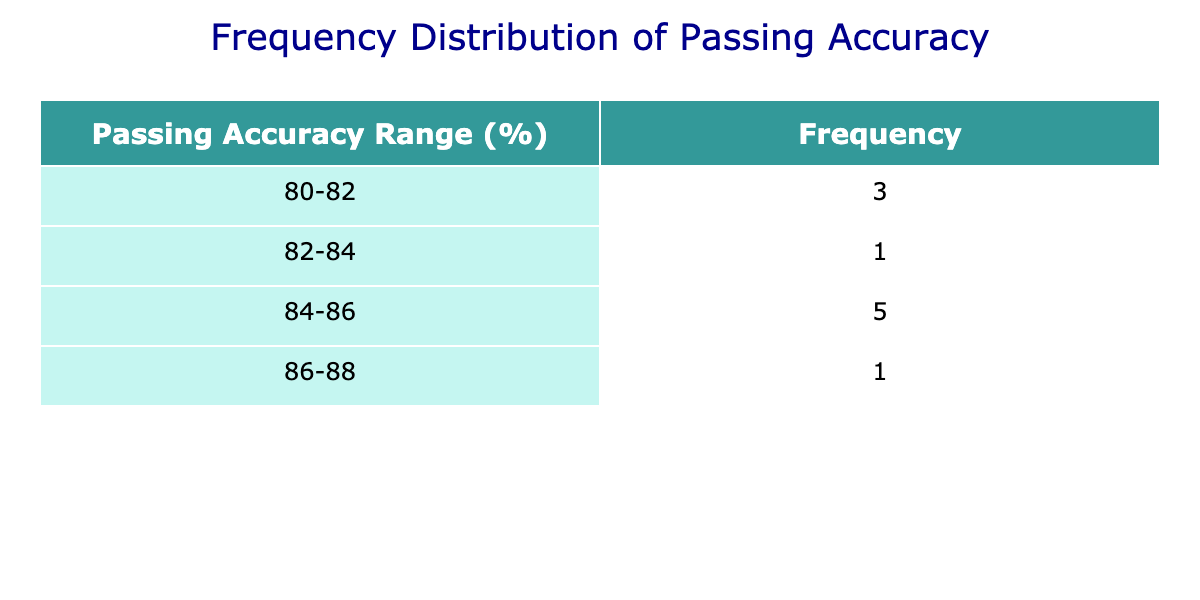What is the frequency of players with a passing accuracy between 84% and 86%? From the table, we look at the 'Accuracy Range' column and find the grouping '84-86'. The count in this category is 5 players: Kevin De Bruyne, Luka Modrić, Bruno Fernandes, Thomas Müller, and N'Golo Kanté.
Answer: 5 Which player has the highest passing accuracy? Reviewing the passing accuracy statistics, Kevin De Bruyne has the highest value of 86.7%.
Answer: Kevin De Bruyne Is there any player with a passing accuracy below 80%? By inspecting the table, the lowest recorded passing accuracy is 80%, attributed to both Jordan Henderson and Marco Verratti. Hence, there are no players below 80%.
Answer: No What is the average passing accuracy of players with a frequency of 2? The only accuracy range with a frequency of 2 is '80-82', corresponding to Jordan Henderson and Marco Verratti, whose accuracies are both 80.0%. The average is (80.0 + 80.0) / 2 = 80.0.
Answer: 80.0 How many players achieved a passing accuracy higher than 85%? We count the players categorized in the '86-88' and '84-86' ranges. From the data, Kevin De Bruyne and Luka Modrić fall into these categories, totaling 2 players.
Answer: 2 How does the passing accuracy of Thomas Müller compare to the average of all players? First, we calculate the average passing accuracy: (86.7 + 85.7 + 84.6 + 84.1 + 84.2 + 84.5 + 83.3 + 80.0 + 80.0 + 81.3) / 10 = 83.82. Thomas Müller has an accuracy of 84.1, which is higher than the average of 83.82.
Answer: Higher What is the total number of passes completed by players with a passing accuracy below 84%? From the players with accuracies 83.3 and below, Lorenzo Pellegrini has 750, Jordan Henderson has 800, Marco Verratti has 760, and Christian Eriksen has 650. Adding these up: 750 + 800 + 760 + 650 = 2960.
Answer: 2960 What proportion of players have a passing accuracy of 82% or lower? Inspecting the frequency distribution, there are 2 players in the '80-82' category out of a total of 10 players. Therefore, the proportion is 2/10 = 0.2 or 20%.
Answer: 20% 